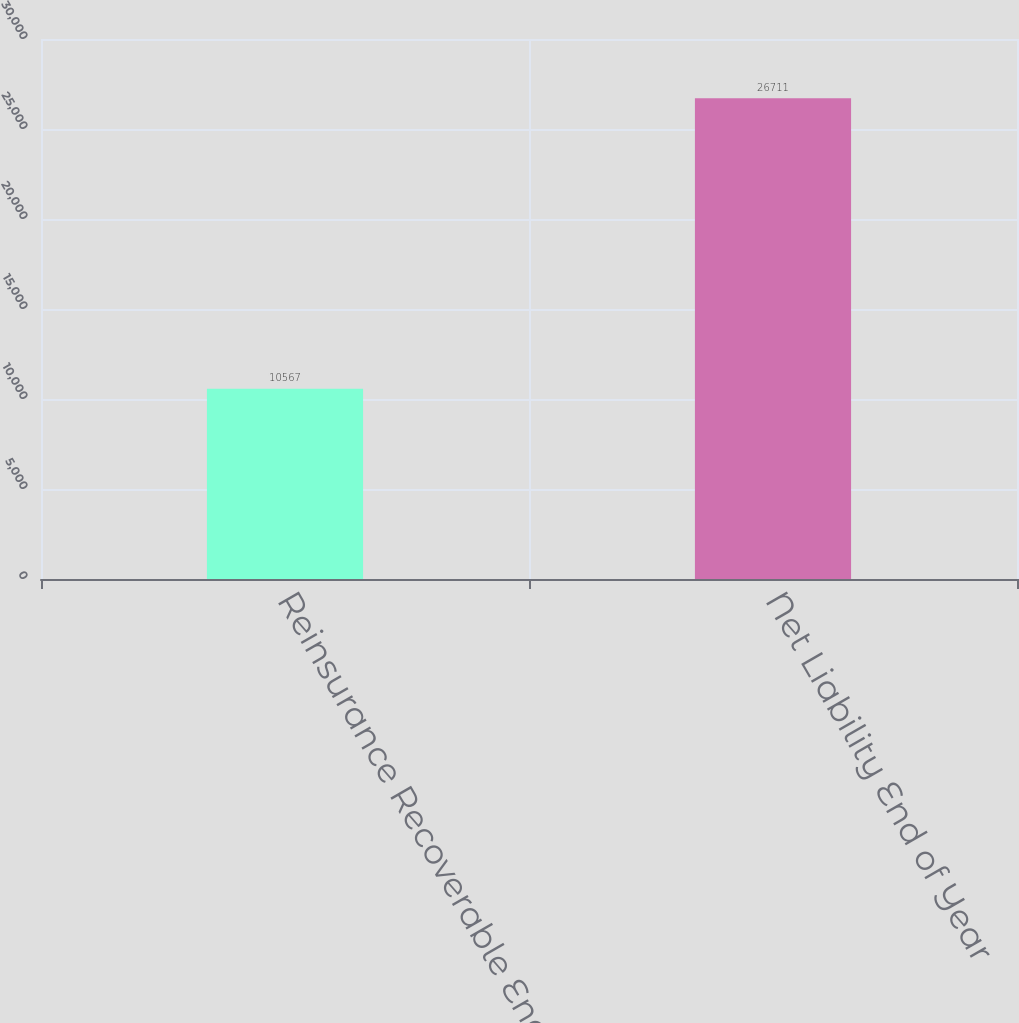Convert chart to OTSL. <chart><loc_0><loc_0><loc_500><loc_500><bar_chart><fcel>Reinsurance Recoverable End of<fcel>Net Liability End of Year<nl><fcel>10567<fcel>26711<nl></chart> 